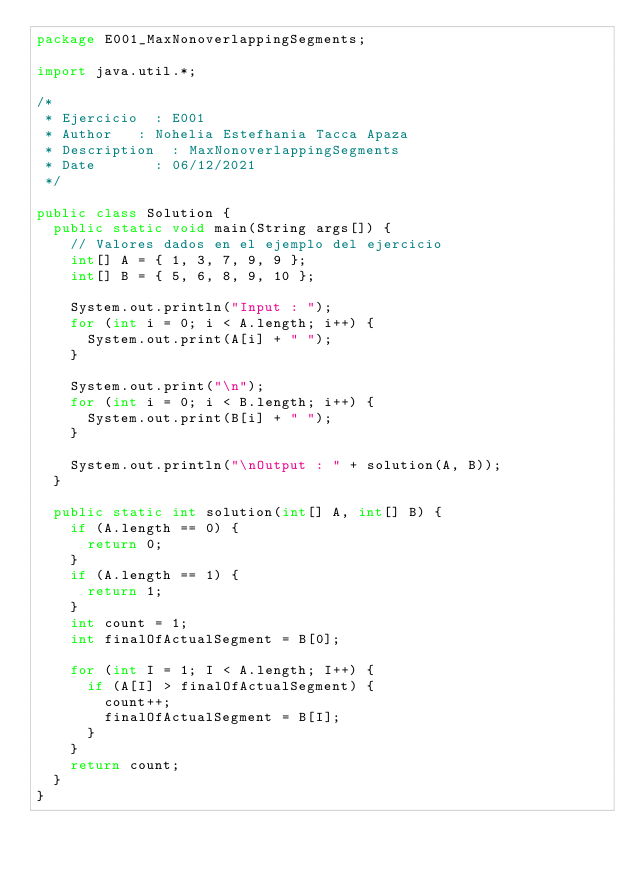<code> <loc_0><loc_0><loc_500><loc_500><_Java_>package E001_MaxNonoverlappingSegments;

import java.util.*;

/*
 * Ejercicio	: E001
 * Author		: Nohelia Estefhania Tacca Apaza
 * Description	: MaxNonoverlappingSegments 
 * Date	  		: 06/12/2021
 */

public class Solution {
	public static void main(String args[]) {
		// Valores dados en el ejemplo del ejercicio
		int[] A = { 1, 3, 7, 9, 9 };
		int[] B = { 5, 6, 8, 9, 10 };

		System.out.println("Input : ");
		for (int i = 0; i < A.length; i++) {
			System.out.print(A[i] + " ");
		}

		System.out.print("\n");
		for (int i = 0; i < B.length; i++) {
			System.out.print(B[i] + " ");
		}

		System.out.println("\nOutput : " + solution(A, B));
	}

	public static int solution(int[] A, int[] B) {
		if (A.length == 0) {
			return 0; 
		}
		if (A.length == 1) {
			return 1; 
		}
		int count = 1;
		int finalOfActualSegment = B[0];

		for (int I = 1; I < A.length; I++) {
			if (A[I] > finalOfActualSegment) {
				count++;
				finalOfActualSegment = B[I];
			}
		}
		return count;
	}
}
</code> 